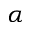Convert formula to latex. <formula><loc_0><loc_0><loc_500><loc_500>\alpha</formula> 